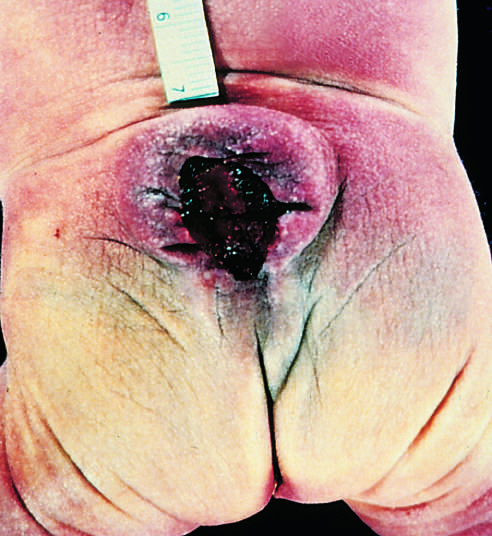re both meninges and spinal cord parenchyma included in the cystlike structure visible just above the buttocks?
Answer the question using a single word or phrase. Yes 